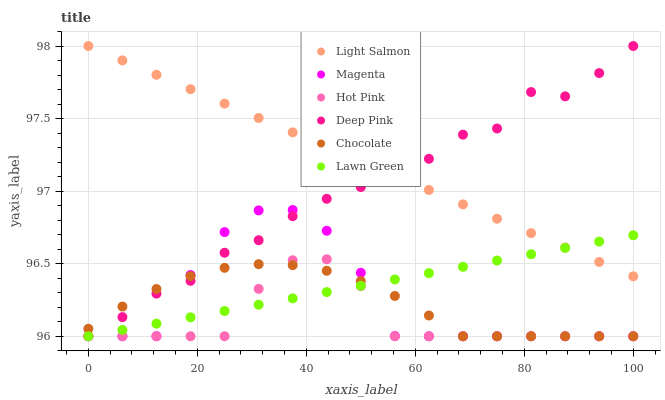Does Hot Pink have the minimum area under the curve?
Answer yes or no. Yes. Does Light Salmon have the maximum area under the curve?
Answer yes or no. Yes. Does Deep Pink have the minimum area under the curve?
Answer yes or no. No. Does Deep Pink have the maximum area under the curve?
Answer yes or no. No. Is Light Salmon the smoothest?
Answer yes or no. Yes. Is Magenta the roughest?
Answer yes or no. Yes. Is Deep Pink the smoothest?
Answer yes or no. No. Is Deep Pink the roughest?
Answer yes or no. No. Does Lawn Green have the lowest value?
Answer yes or no. Yes. Does Light Salmon have the lowest value?
Answer yes or no. No. Does Deep Pink have the highest value?
Answer yes or no. Yes. Does Hot Pink have the highest value?
Answer yes or no. No. Is Hot Pink less than Light Salmon?
Answer yes or no. Yes. Is Light Salmon greater than Hot Pink?
Answer yes or no. Yes. Does Deep Pink intersect Chocolate?
Answer yes or no. Yes. Is Deep Pink less than Chocolate?
Answer yes or no. No. Is Deep Pink greater than Chocolate?
Answer yes or no. No. Does Hot Pink intersect Light Salmon?
Answer yes or no. No. 